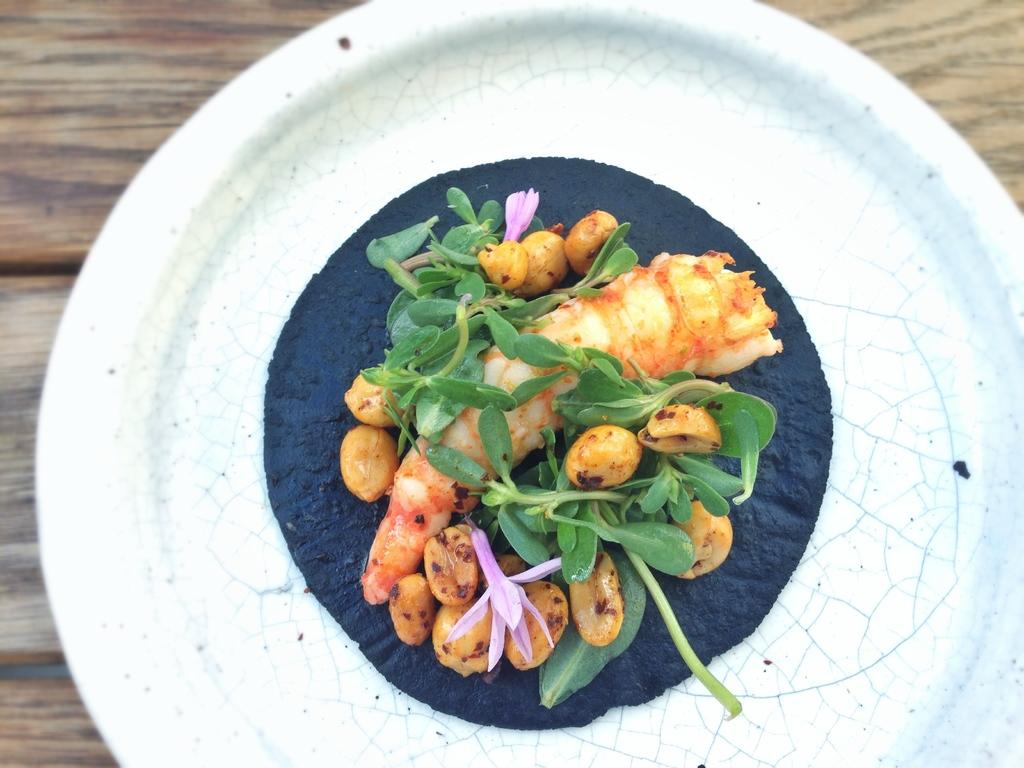What object is present in the image that typically holds food? There is a plate in the image that typically holds food. What is on the plate in the image? The plate contains food. Where is the plate located in the image? The plate is placed on a table. What type of watch can be seen on the plate in the image? There is no watch present on the plate in the image; it contains food. 